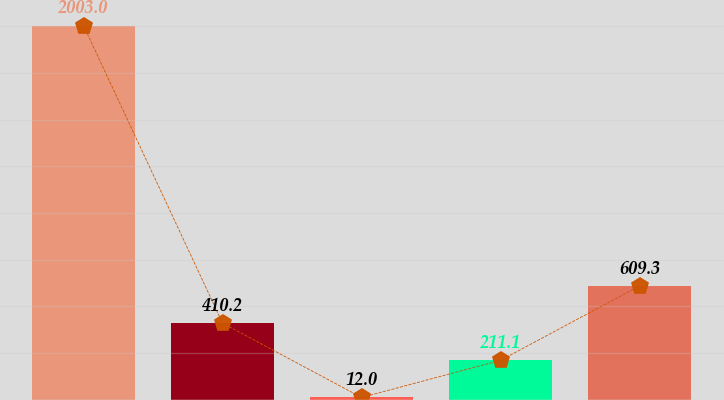Convert chart. <chart><loc_0><loc_0><loc_500><loc_500><bar_chart><fcel>In millions<fcel>US plans (non-cash)<fcel>Non-US plans<fcel>US plans<fcel>Net expense<nl><fcel>2003<fcel>410.2<fcel>12<fcel>211.1<fcel>609.3<nl></chart> 